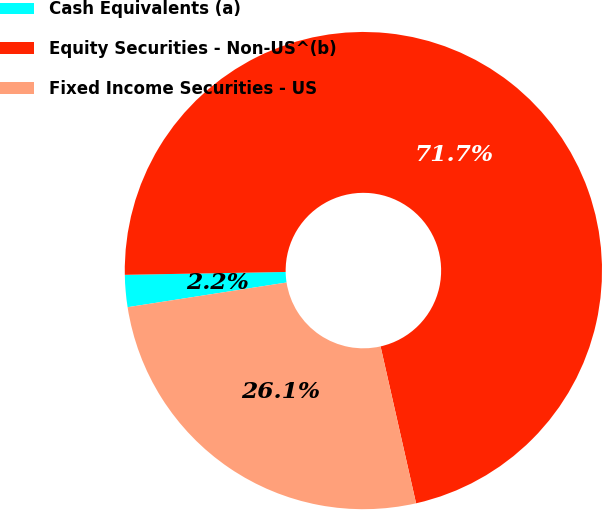Convert chart. <chart><loc_0><loc_0><loc_500><loc_500><pie_chart><fcel>Cash Equivalents (a)<fcel>Equity Securities - Non-US^(b)<fcel>Fixed Income Securities - US<nl><fcel>2.17%<fcel>71.74%<fcel>26.09%<nl></chart> 